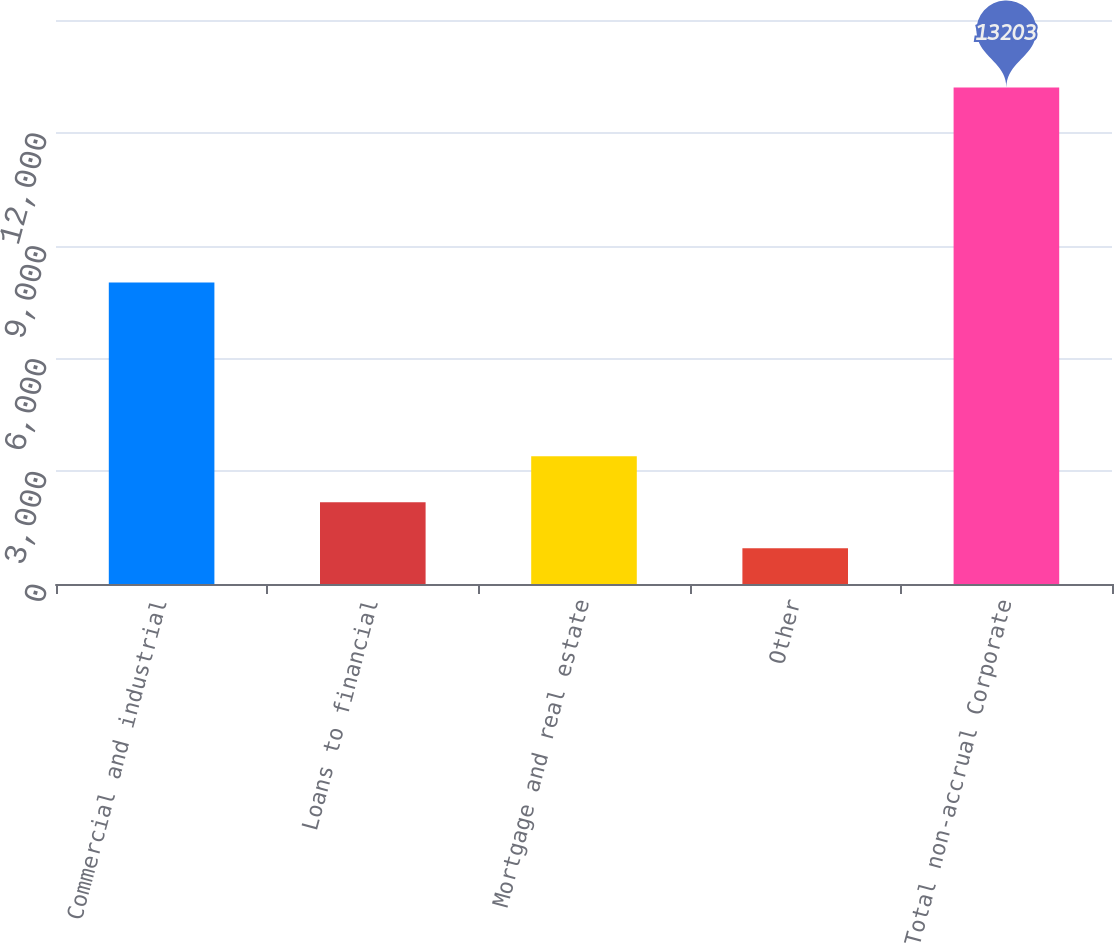Convert chart to OTSL. <chart><loc_0><loc_0><loc_500><loc_500><bar_chart><fcel>Commercial and industrial<fcel>Loans to financial<fcel>Mortgage and real estate<fcel>Other<fcel>Total non-accrual Corporate<nl><fcel>8021<fcel>2173.5<fcel>3399<fcel>948<fcel>13203<nl></chart> 